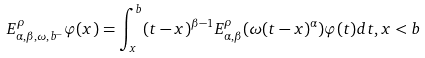<formula> <loc_0><loc_0><loc_500><loc_500>E ^ { \rho } _ { \alpha , \beta , \omega , b ^ { - } } \varphi ( x ) = \int _ { x } ^ { b } ( t - x ) ^ { \beta - 1 } E _ { \alpha , \beta } ^ { \rho } ( \omega ( t - x ) ^ { \alpha } ) \varphi ( t ) d t , x < b</formula> 